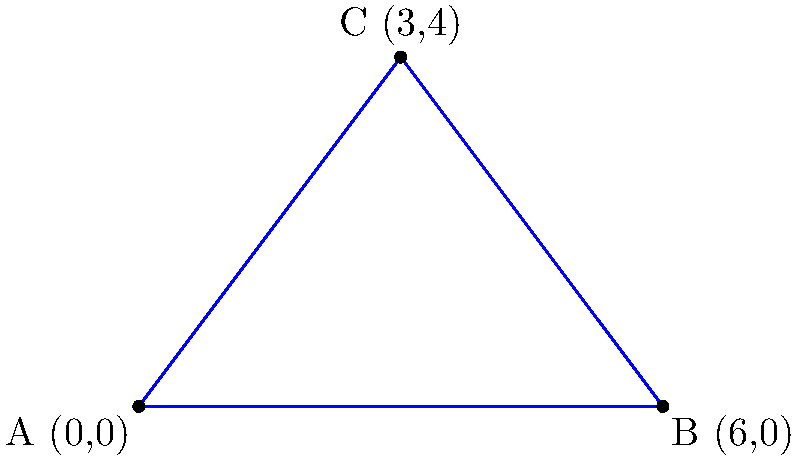A group of seals has discovered a triangular safe zone in their habitat, away from orca hunting grounds. The safe zone is represented by a triangle with vertices at A(0,0), B(6,0), and C(3,4). Calculate the area of this triangular safe zone to determine how many seals can seek refuge there. To find the area of the triangular safe zone, we'll use the formula for the area of a triangle given the coordinates of its vertices:

Area = $\frac{1}{2}|x_1(y_2 - y_3) + x_2(y_3 - y_1) + x_3(y_1 - y_2)|$

Where $(x_1, y_1)$, $(x_2, y_2)$, and $(x_3, y_3)$ are the coordinates of the three vertices.

Step 1: Identify the coordinates
A: $(x_1, y_1) = (0, 0)$
B: $(x_2, y_2) = (6, 0)$
C: $(x_3, y_3) = (3, 4)$

Step 2: Substitute the values into the formula
Area = $\frac{1}{2}|0(0 - 4) + 6(4 - 0) + 3(0 - 0)|$

Step 3: Simplify
Area = $\frac{1}{2}|0 + 24 + 0|$
Area = $\frac{1}{2}|24|$
Area = $\frac{1}{2}(24)$
Area = 12

Therefore, the area of the triangular safe zone is 12 square units.
Answer: 12 square units 